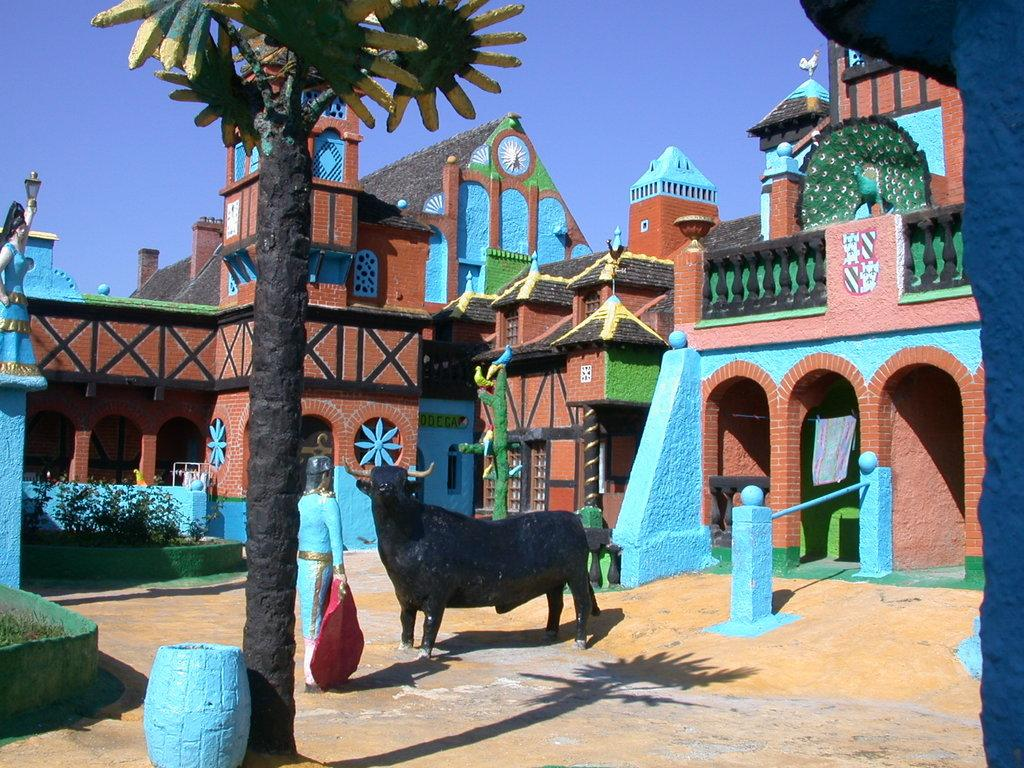What type of sculptures can be seen in the foreground of the image? There are sculptures of a tree, a bull, a man, and buildings in the foreground of the image. What can be seen in the background of the image? The sky is visible in the image. What is the surface on which the sculptures are placed? The floor is visible in the image. How many ants are crawling on the sculptures in the image? There are no ants visible on the sculptures in the image. What type of society is depicted by the sculptures in the image? The sculptures in the image do not depict a specific society; they are individual sculptures of a tree, a bull, a man, and buildings. 